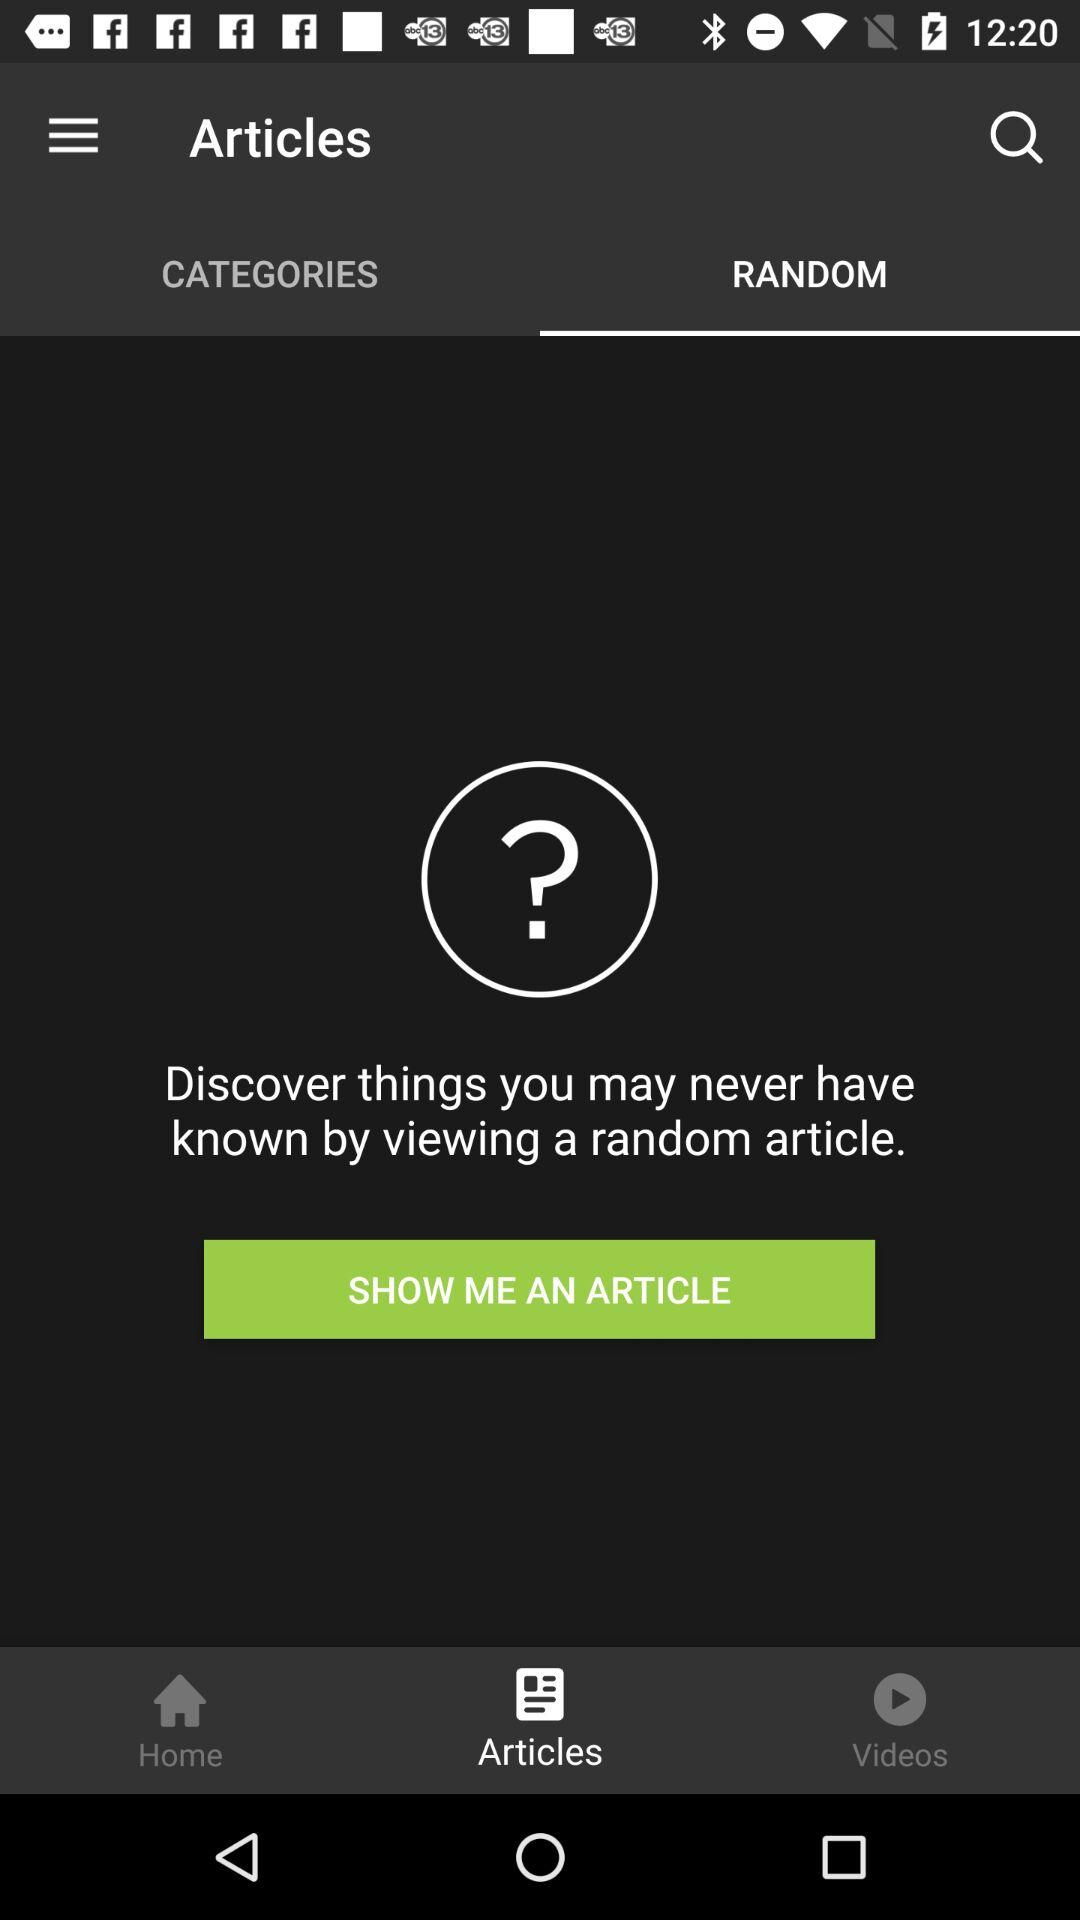Which tab is selected in articles? The selected tab is "RANDOM". 